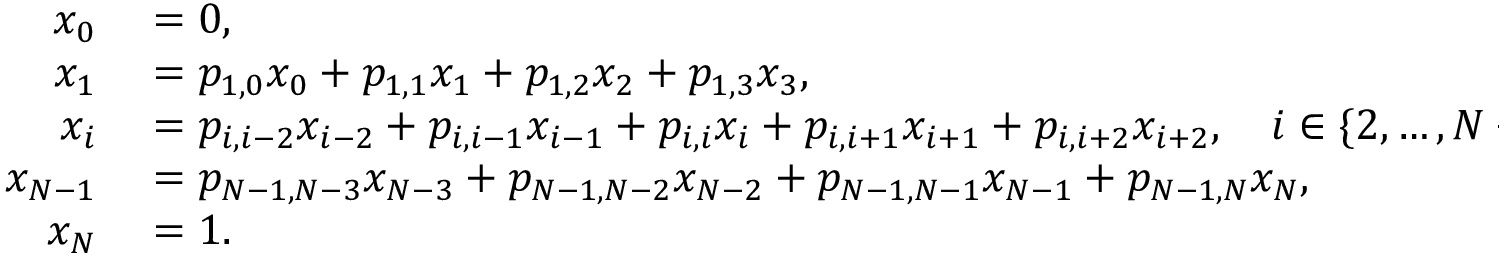<formula> <loc_0><loc_0><loc_500><loc_500>\begin{array} { r l } { x _ { 0 } } & = 0 , } \\ { x _ { 1 } } & = p _ { 1 , 0 } x _ { 0 } + p _ { 1 , 1 } x _ { 1 } + p _ { 1 , 2 } x _ { 2 } + p _ { 1 , 3 } x _ { 3 } , } \\ { x _ { i } } & = p _ { i , i - 2 } x _ { i - 2 } + p _ { i , i - 1 } x _ { i - 1 } + p _ { i , i } x _ { i } + p _ { i , i + 1 } x _ { i + 1 } + p _ { i , i + 2 } x _ { i + 2 } , \quad i \in \{ 2 , \dots , N - 2 \} , } \\ { x _ { N - 1 } } & = p _ { N - 1 , N - 3 } x _ { N - 3 } + p _ { N - 1 , N - 2 } x _ { N - 2 } + p _ { N - 1 , N - 1 } x _ { N - 1 } + p _ { N - 1 , N } x _ { N } , } \\ { x _ { N } } & = 1 . } \end{array}</formula> 